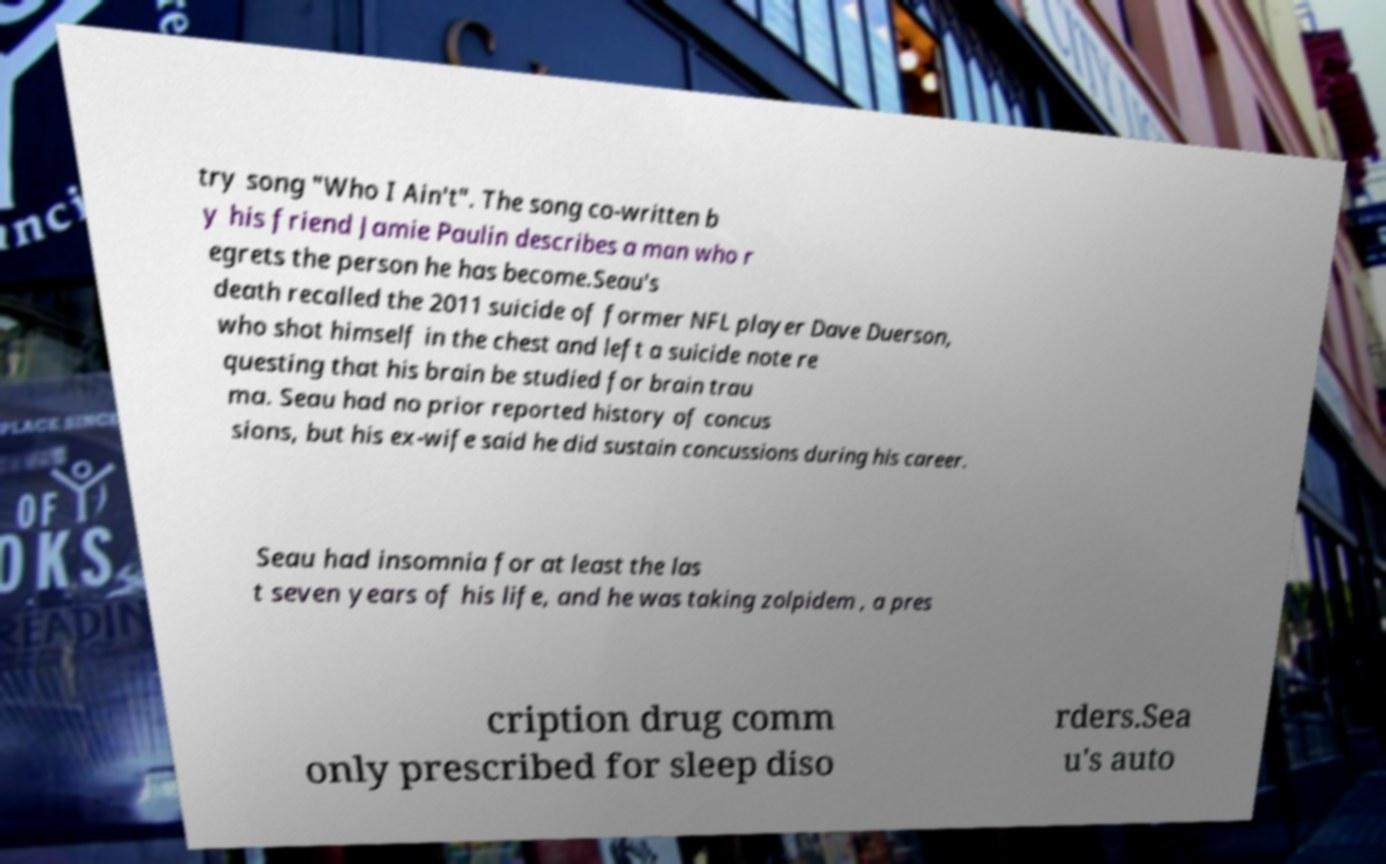There's text embedded in this image that I need extracted. Can you transcribe it verbatim? try song "Who I Ain't". The song co-written b y his friend Jamie Paulin describes a man who r egrets the person he has become.Seau's death recalled the 2011 suicide of former NFL player Dave Duerson, who shot himself in the chest and left a suicide note re questing that his brain be studied for brain trau ma. Seau had no prior reported history of concus sions, but his ex-wife said he did sustain concussions during his career. Seau had insomnia for at least the las t seven years of his life, and he was taking zolpidem , a pres cription drug comm only prescribed for sleep diso rders.Sea u's auto 